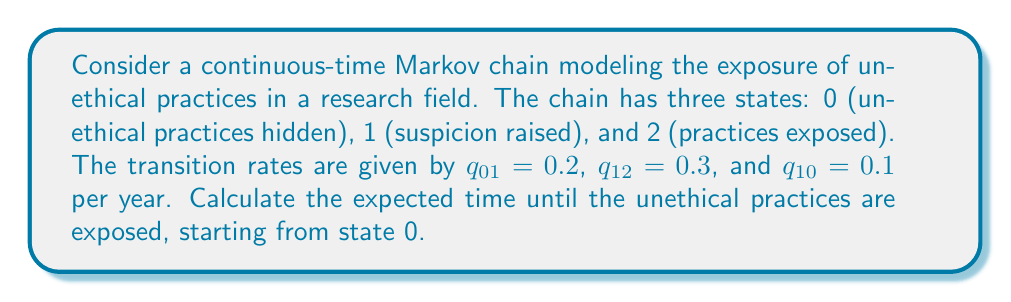Give your solution to this math problem. To solve this problem, we'll use the concept of hitting times in continuous-time Markov chains.

Step 1: Define the hitting time
Let $T_2$ be the hitting time of state 2 (practices exposed).

Step 2: Set up the system of equations
Let $h_i = E[T_2 | X(0) = i]$ be the expected hitting time starting from state $i$. We need to solve:

$$\begin{align}
h_0 &= \frac{1}{q_{01}} + h_1 \\
h_1 &= \frac{1}{q_{12} + q_{10}} + \frac{q_{10}}{q_{12} + q_{10}}h_0 \\
h_2 &= 0
\end{align}$$

Step 3: Substitute the given values
$$\begin{align}
h_0 &= \frac{1}{0.2} + h_1 \\
h_1 &= \frac{1}{0.3 + 0.1} + \frac{0.1}{0.3 + 0.1}h_0
\end{align}$$

Step 4: Solve the system of equations
From the second equation:
$$h_1 = 2.5 + 0.25h_0$$

Substitute this into the first equation:
$$h_0 = 5 + (2.5 + 0.25h_0)$$
$$h_0 = 7.5 + 0.25h_0$$
$$0.75h_0 = 7.5$$
$$h_0 = 10$$

Step 5: Interpret the result
The expected time until the unethical practices are exposed, starting from state 0, is 10 years.
Answer: 10 years 